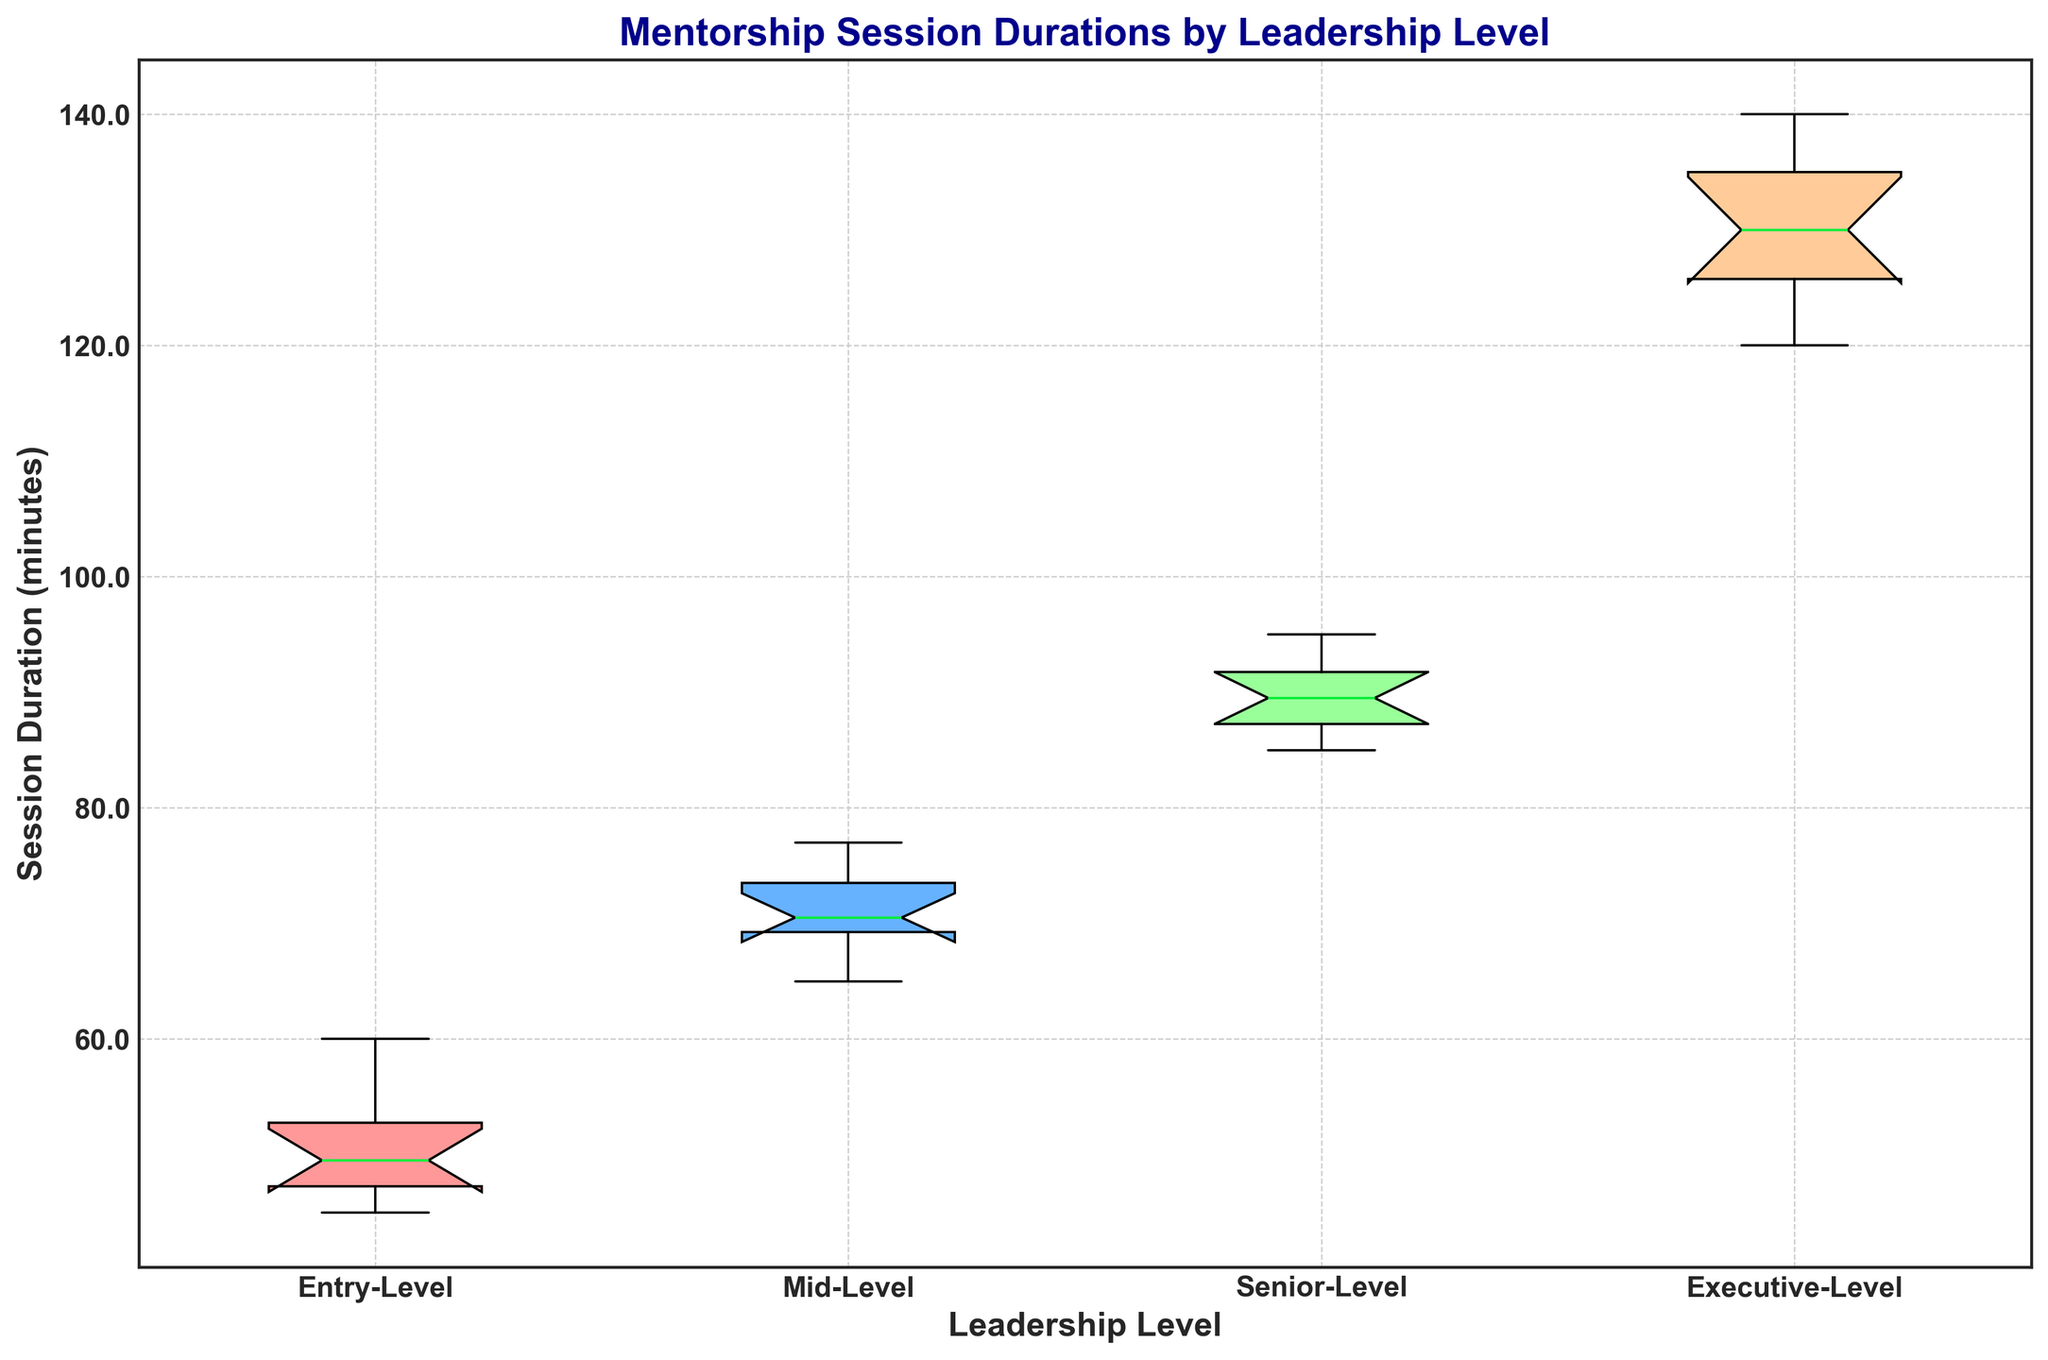What's the median session duration for Entry-Level mentorship sessions? The median is the middle value when the numbers are sorted in ascending order. For Entry-Level sessions, the durations are: 45, 47, 47, 48, 49, 50, 52, 53, 55, 60. The median is (49+50)/2 = 49.5
Answer: 49.5 Which leadership level has the highest median session duration? We need to look at the central mark within each box in the box plot. The executive level has the highest median, as it is around 130 minutes.
Answer: Executive-Level Is the average session duration for Senior-Level greater than Mid-Level? We compare the median (central mark) of Senior-Level and Mid-Level boxes. Senior-Level's median is around 90, and Mid-Level's is about 70. Yes, the Senior-Level median is greater.
Answer: Yes Which group shows the largest spread in session durations? We need to look at the length of the boxes (the interquartile range). The Executive-Level box is the largest, indicating the highest spread.
Answer: Executive-Level What is the range of session durations for Executive-Level? The range is calculated by subtracting the smallest value from the largest value within the whiskers. For Executive-Level, the smallest is 120, and the largest is 140. The range is 140 - 120.
Answer: 20 Are there any outliers in any of the leadership levels? Outliers are typically shown as dots outside the whiskers. There are no dots or marks outside the whiskers in the box plot, indicating no outliers.
Answer: No What is the interquartile range (IQR) for Mid-Level mentorship sessions? The IQR is the difference between the upper and lower quartiles (Q3 - Q1). For Mid-Level, Q1 is around 68 and Q3 is around 75, so the IQR is 75 - 68.
Answer: 7 Compare the median session duration between Entry-Level and Senior-Level. Which is higher? Look at the central marks in the boxes for Entry-Level and Senior-Level. The median for Entry-Level is around 50 while for Senior-Level it is around 90. The Senior-Level is higher.
Answer: Senior-Level How does the session duration variability of Entry-Level compare to Mid-Level? Variability is indicated by the length of the box and whiskers. Entry-Level has shorter boxes and whiskers compared to Mid-Level, indicating it has less variability.
Answer: Less What is the median session duration for Executive-Level mentorship sessions? The median is the central mark within the Executive-Level box. The median for Executive-Level is around 130.
Answer: 130 